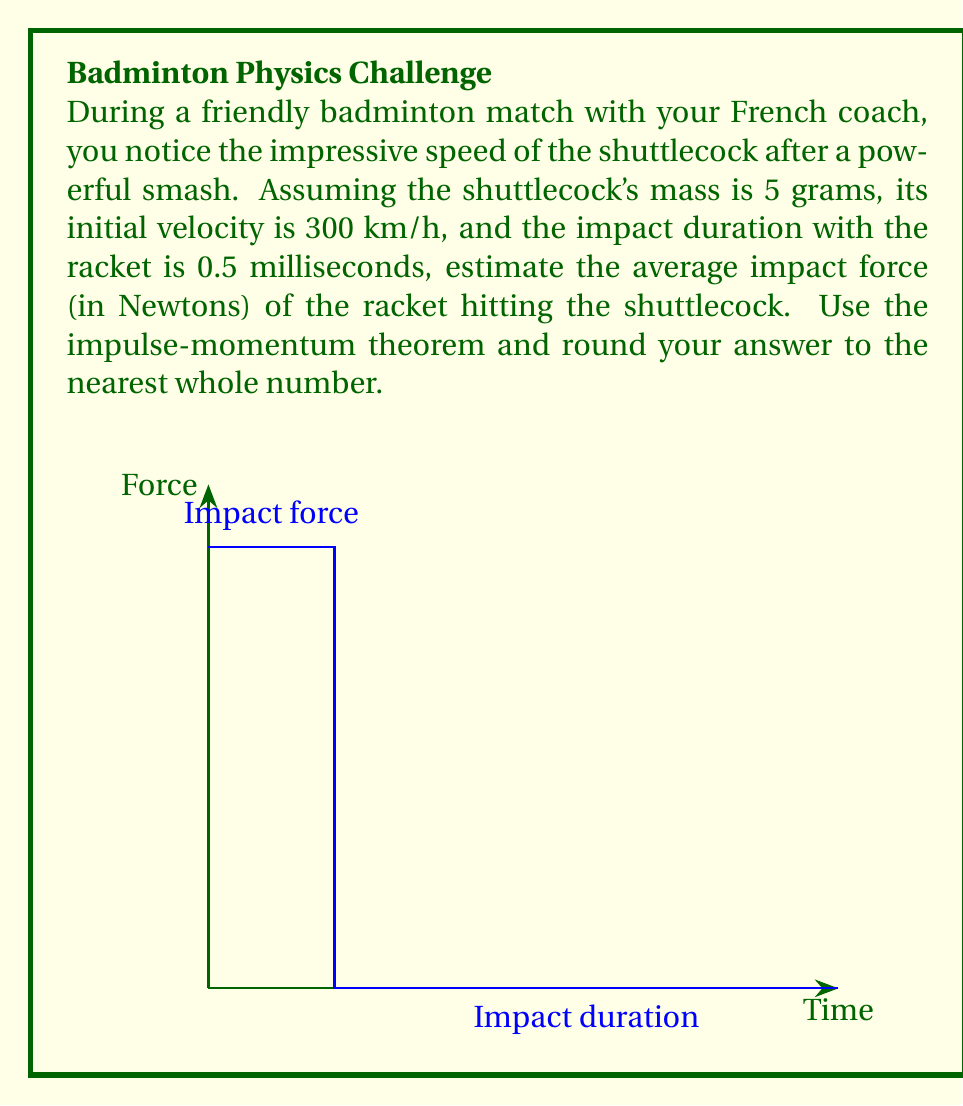Teach me how to tackle this problem. Let's approach this step-by-step using the impulse-momentum theorem:

1) First, convert the initial velocity to m/s:
   $$ 300 \text{ km/h} = 300 \times \frac{1000}{3600} = 83.33 \text{ m/s} $$

2) The impulse-momentum theorem states that the change in momentum equals the impulse:
   $$ F \Delta t = m \Delta v $$
   where $F$ is the average force, $\Delta t$ is the time interval, $m$ is the mass, and $\Delta v$ is the change in velocity.

3) In this case:
   - $m = 5 \text{ g} = 0.005 \text{ kg}$
   - $\Delta v = 83.33 \text{ m/s} - 0 = 83.33 \text{ m/s}$ (assuming the shuttlecock comes to a complete stop at impact)
   - $\Delta t = 0.5 \text{ ms} = 0.0005 \text{ s}$

4) Substituting these values into the equation:
   $$ F \times 0.0005 = 0.005 \times 83.33 $$

5) Solving for $F$:
   $$ F = \frac{0.005 \times 83.33}{0.0005} = 833.3 \text{ N} $$

6) Rounding to the nearest whole number:
   $$ F \approx 833 \text{ N} $$
Answer: 833 N 